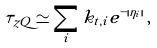Convert formula to latex. <formula><loc_0><loc_0><loc_500><loc_500>\tau _ { z Q } \simeq \sum _ { i } k _ { t , i } e ^ { - | \eta _ { i } | } \, ,</formula> 